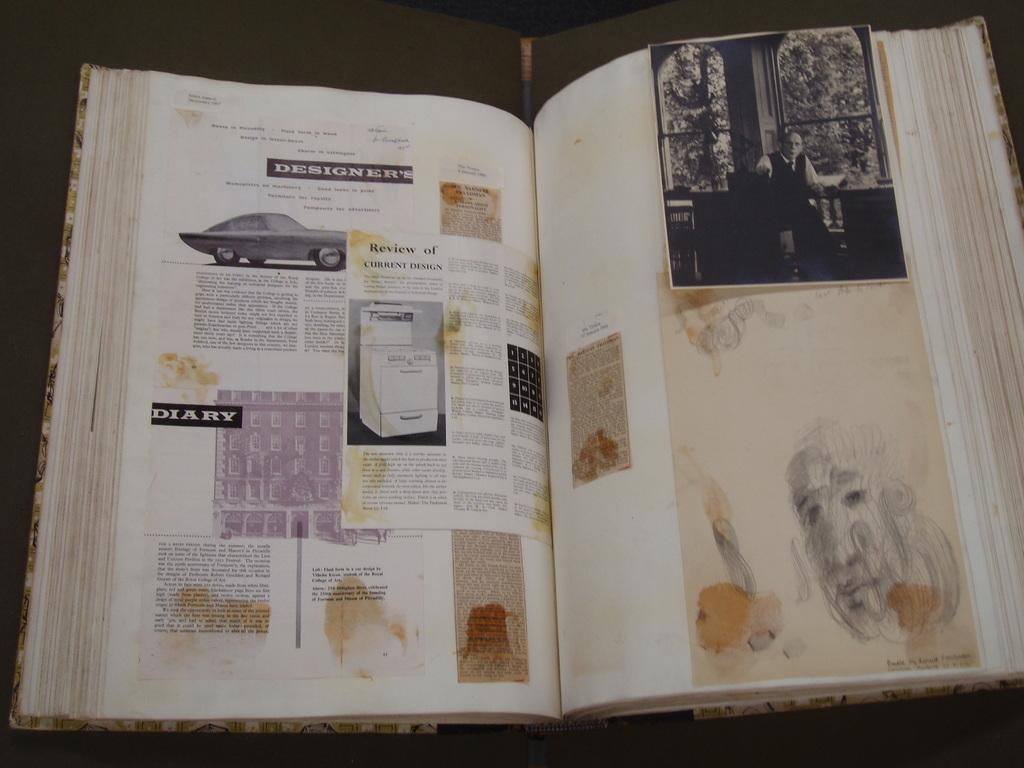<image>
Relay a brief, clear account of the picture shown. A scrapbook that has various articles pasted in it and one is titled Designers 